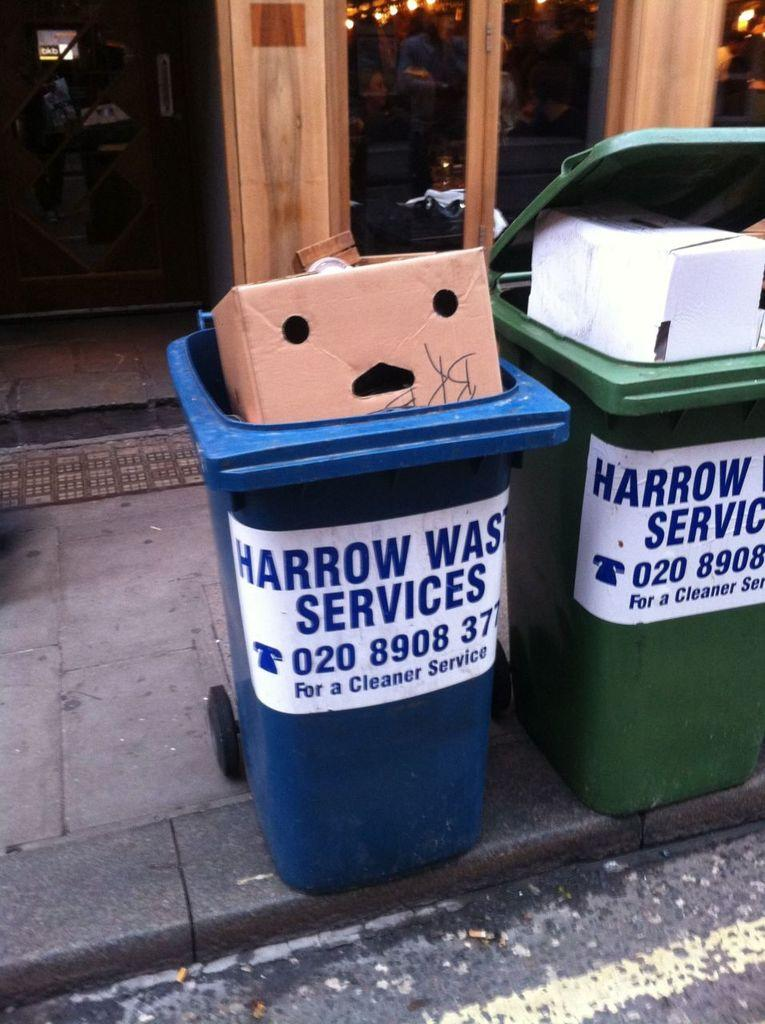<image>
Relay a brief, clear account of the picture shown. A box with holes cut in it sits in the top of a Harrow Waste Services bin. 